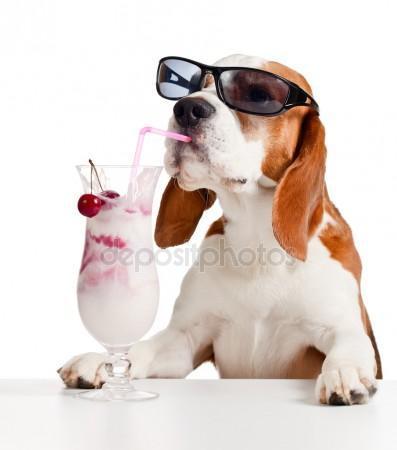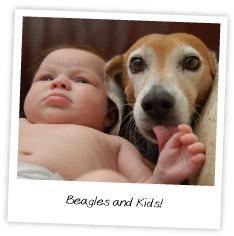The first image is the image on the left, the second image is the image on the right. Given the left and right images, does the statement "A beagle is eating sausages." hold true? Answer yes or no. No. 